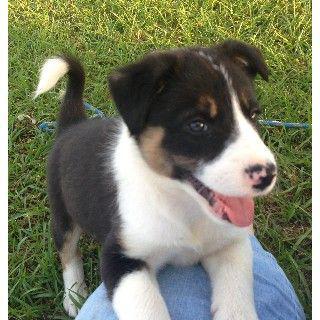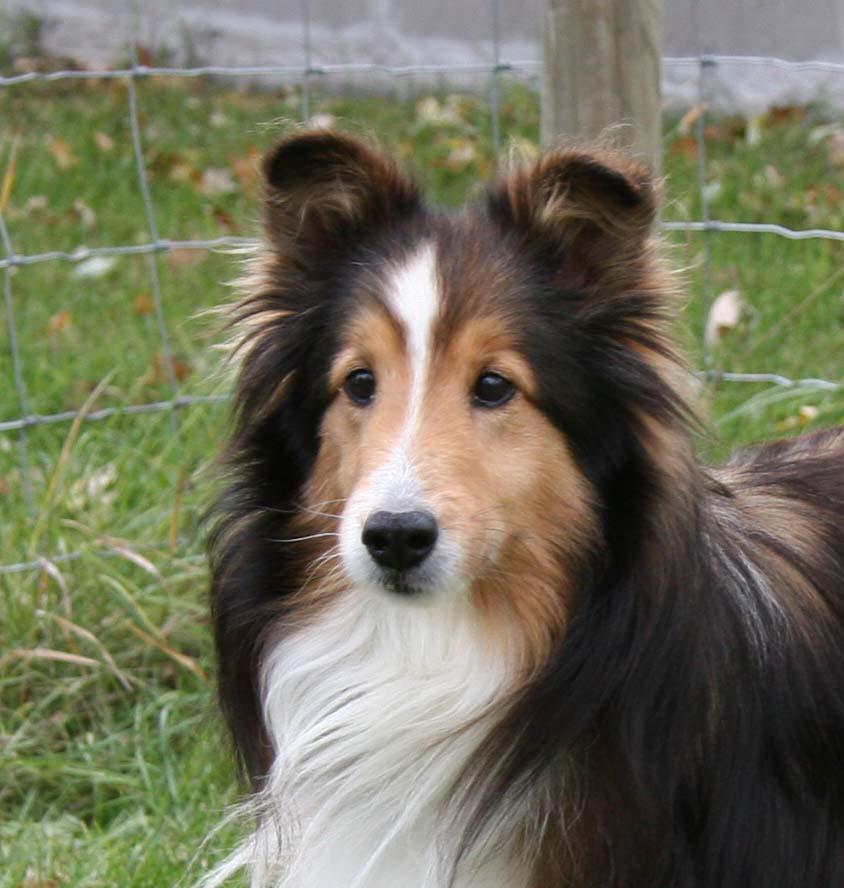The first image is the image on the left, the second image is the image on the right. Assess this claim about the two images: "No single image contains more than two dogs, all images show dogs on a grass background, and at least one image includes a familiar collie breed.". Correct or not? Answer yes or no. Yes. The first image is the image on the left, the second image is the image on the right. Considering the images on both sides, is "The right image contains exactly two dogs." valid? Answer yes or no. No. 